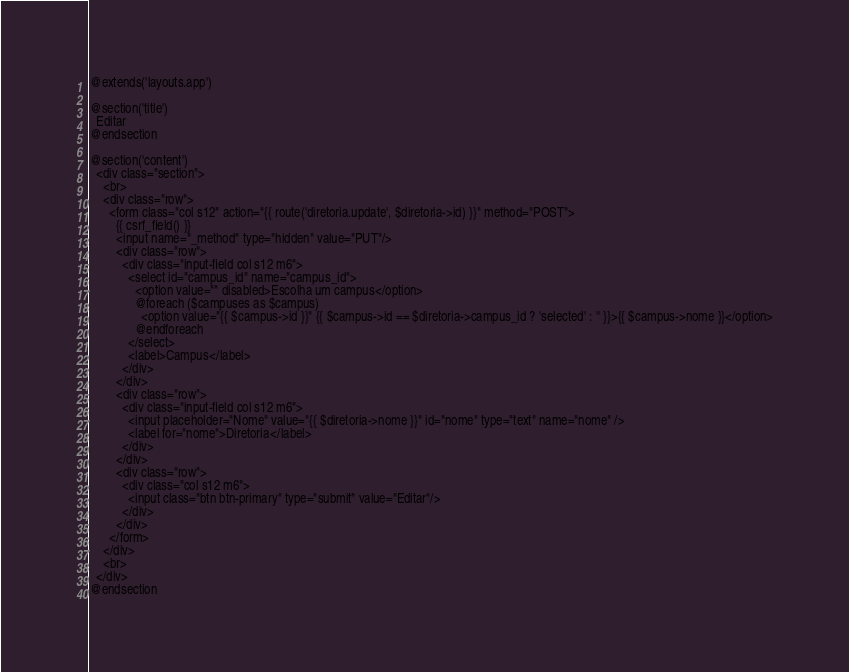Convert code to text. <code><loc_0><loc_0><loc_500><loc_500><_PHP_>@extends('layouts.app')

@section('title')
  Editar
@endsection

@section('content')
  <div class="section">
    <br>
    <div class="row">
      <form class="col s12" action="{{ route('diretoria.update', $diretoria->id) }}" method="POST">
        {{ csrf_field() }}
        <input name="_method" type="hidden" value="PUT"/>
        <div class="row">
          <div class="input-field col s12 m6">
            <select id="campus_id" name="campus_id">
              <option value="" disabled>Escolha um campus</option>
              @foreach ($campuses as $campus)
                <option value="{{ $campus->id }}" {{ $campus->id == $diretoria->campus_id ? 'selected' : '' }}>{{ $campus->nome }}</option>
              @endforeach
            </select>
            <label>Campus</label>
          </div>
        </div>
        <div class="row">
          <div class="input-field col s12 m6">
            <input placeholder="Nome" value="{{ $diretoria->nome }}" id="nome" type="text" name="nome" />
            <label for="nome">Diretoria</label>
          </div>
        </div>
        <div class="row">
          <div class="col s12 m6">
            <input class="btn btn-primary" type="submit" value="Editar"/>
          </div>
        </div>
      </form>
    </div>
    <br>
  </div>
@endsection
</code> 